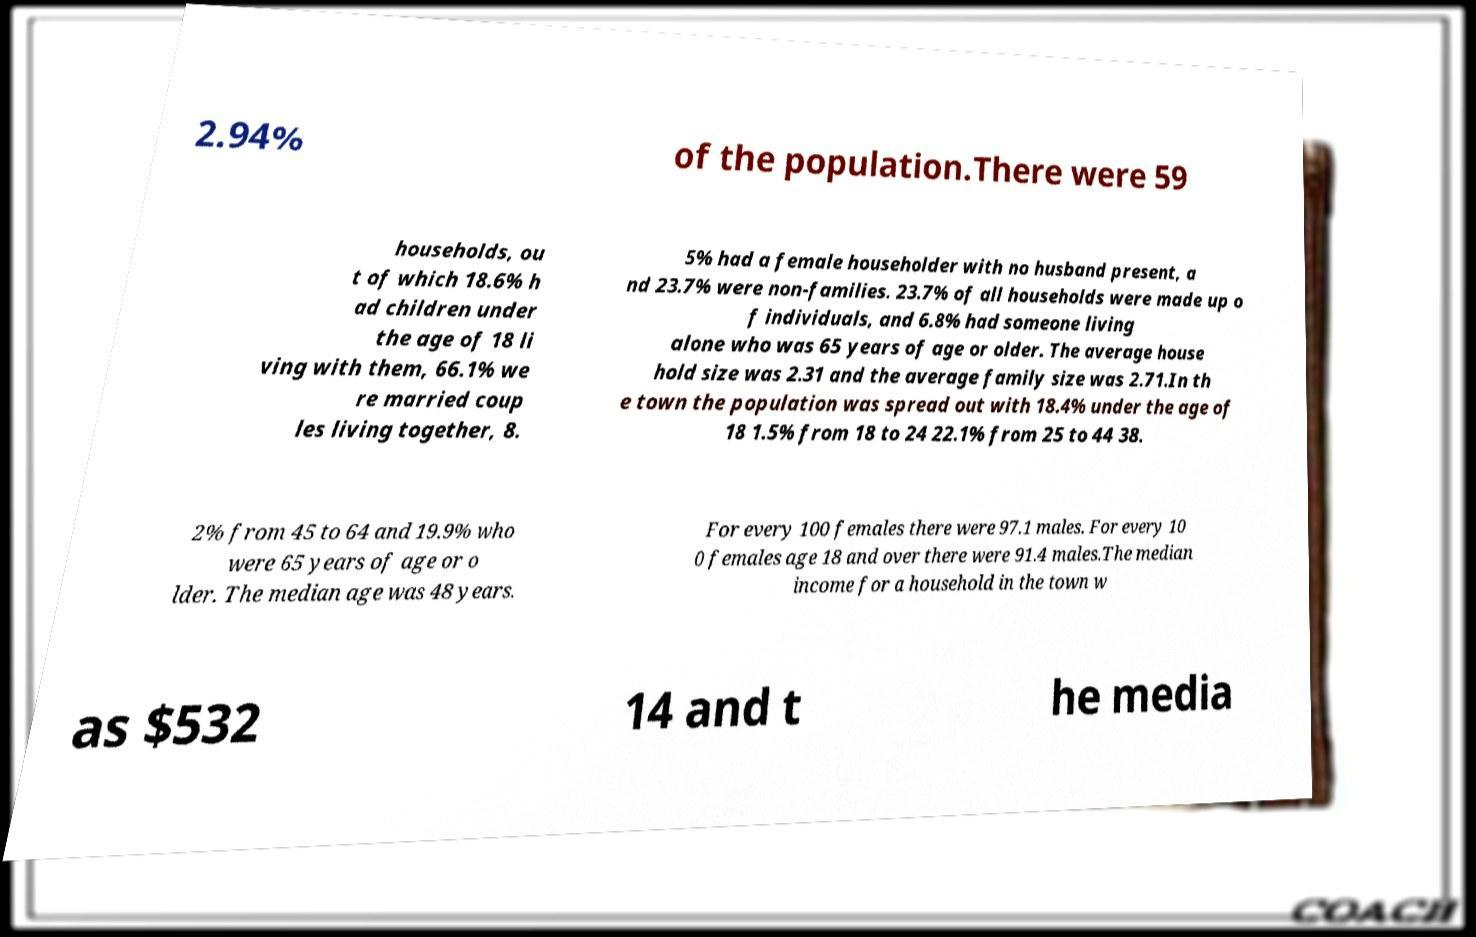For documentation purposes, I need the text within this image transcribed. Could you provide that? 2.94% of the population.There were 59 households, ou t of which 18.6% h ad children under the age of 18 li ving with them, 66.1% we re married coup les living together, 8. 5% had a female householder with no husband present, a nd 23.7% were non-families. 23.7% of all households were made up o f individuals, and 6.8% had someone living alone who was 65 years of age or older. The average house hold size was 2.31 and the average family size was 2.71.In th e town the population was spread out with 18.4% under the age of 18 1.5% from 18 to 24 22.1% from 25 to 44 38. 2% from 45 to 64 and 19.9% who were 65 years of age or o lder. The median age was 48 years. For every 100 females there were 97.1 males. For every 10 0 females age 18 and over there were 91.4 males.The median income for a household in the town w as $532 14 and t he media 